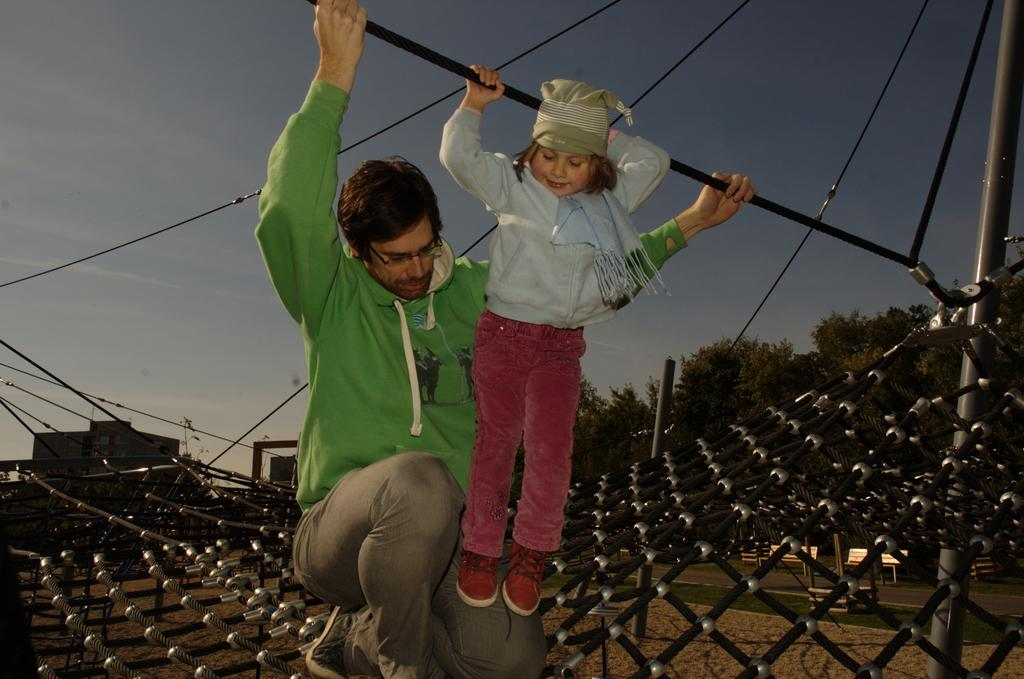Who is present in the image? There is a man and a kid in the image. What are the man and kid holding? The man and kid are holding a rope. What is located at the bottom of the image? There is a net at the bottom of the image. What can be seen on the ground in the image? The ground is visible in the image. What structures can be seen in the background of the image? There are poles, trees, wires, ropes, and benches in the background of the image. What is visible in the sky in the image? The sky is visible in the background of the image. What type of fang can be seen in the image? There is no fang present in the image. What test is being conducted by the man and kid in the image? There is no test being conducted in the image; they are holding a rope. 